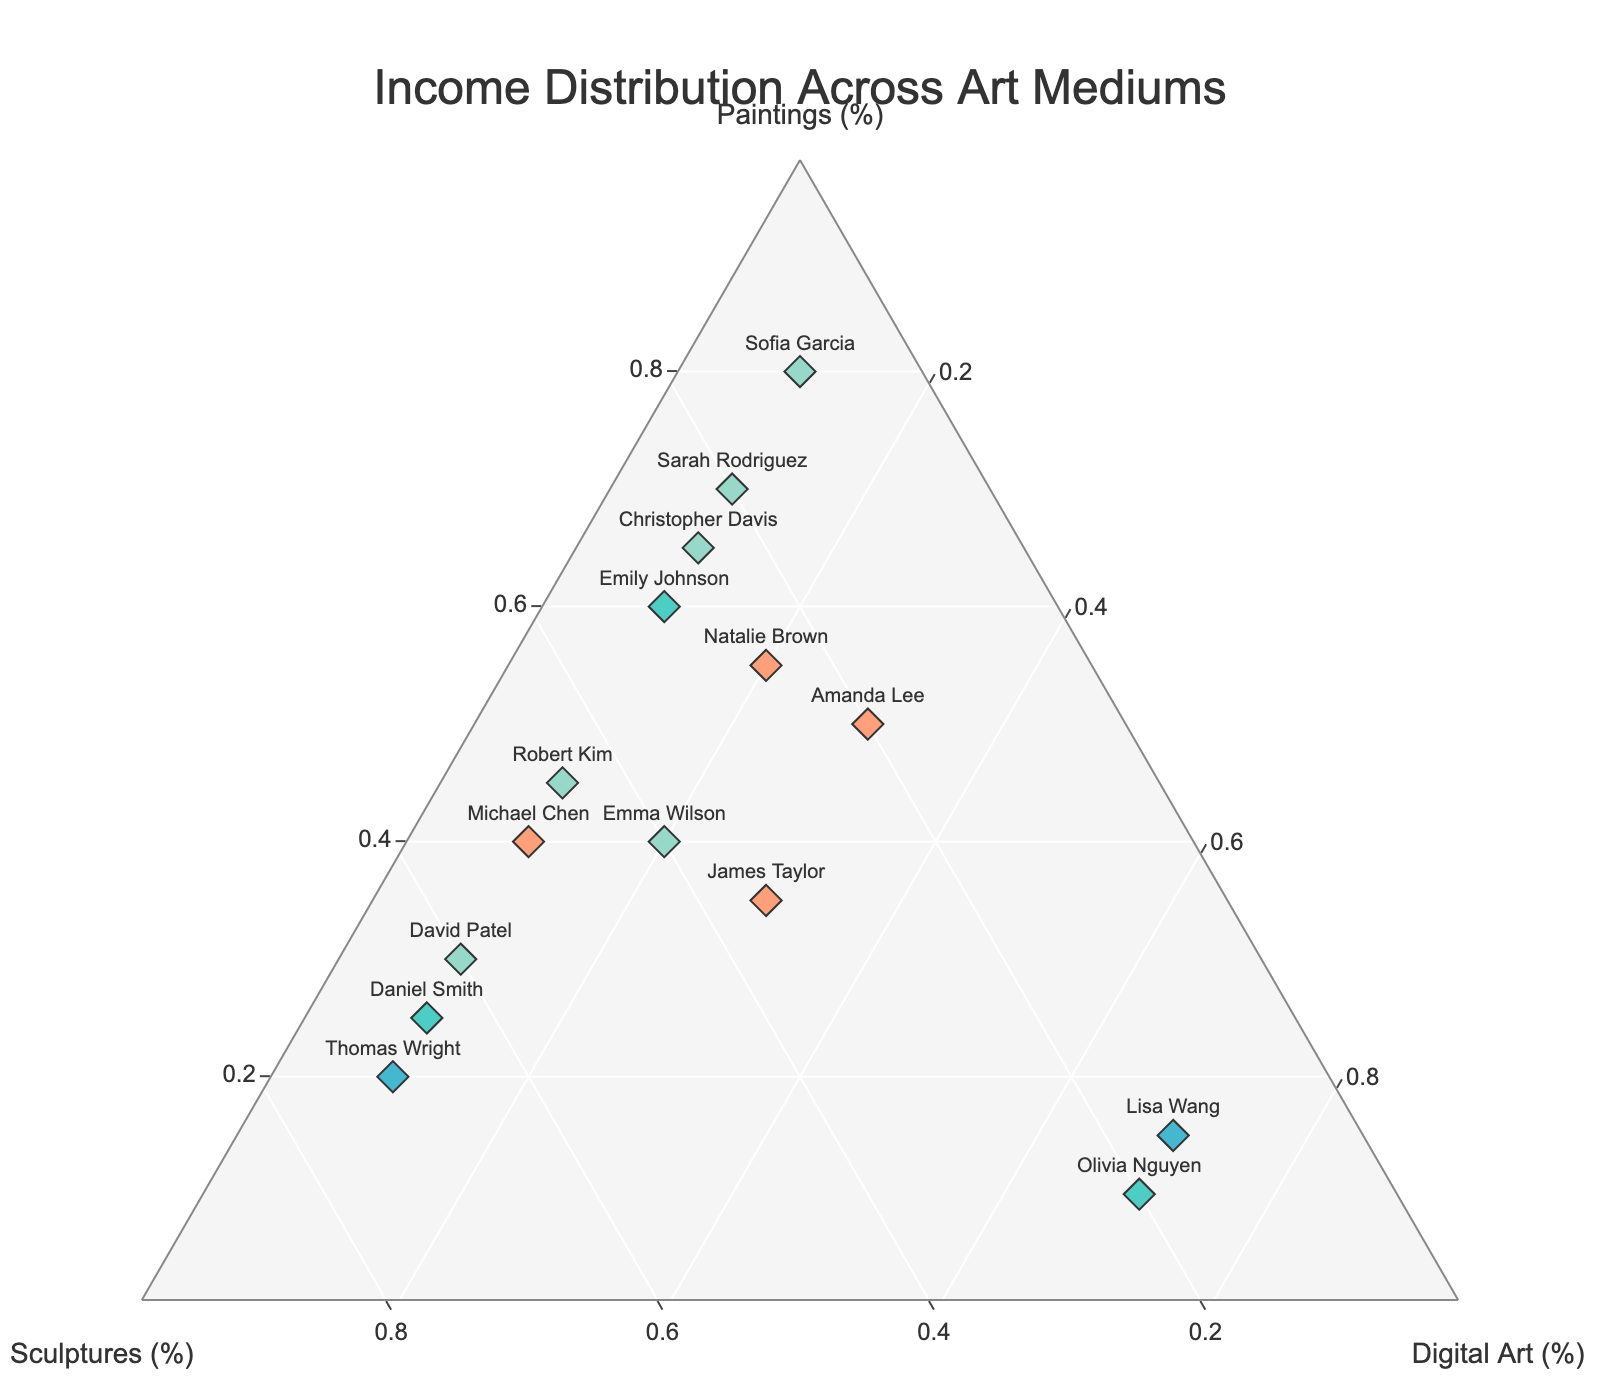What does the ternary plot's title indicate? The title "Income Distribution Across Art Mediums" suggests that the figure shows how different artists' incomes are distributed among paintings, sculptures, and digital art.
Answer: Income Distribution Across Art Mediums What are the axes titles in the ternary plot? The axes titles are "Paintings (%)", "Sculptures (%)", and "Digital Art (%)". Each axis represents the percentage of income from a specific art medium.
Answer: Paintings (%), Sculptures (%), Digital Art (%) Which artist has the highest percentage of income from sculptures? By looking at the ternary plot, the artist whose marker is positioned closest to the sculptures axis (70%) is Thomas Wright.
Answer: Thomas Wright What is the income distribution for Amanda Lee? Amanda Lee's marker is positioned at 50% paintings, 20% sculptures, and 30% digital art. These values are displayed on the plot.
Answer: 50% paintings, 20% sculptures, 30% digital art How many artists have an equal income distribution from paintings and sculptures? Artists with equal income from paintings and sculptures will have their markers along a line where the values for paintings and sculptures are the same. In this case, Michael Chen (40% paintings, 50% sculptures) and Robert Kim (45% paintings, 45% sculptures) fit this description.
Answer: 2 artists What is the total percentage contribution from digital art for all artists combined? To find the total percentage contribution from digital art, sum the digital art percentages for all artists: 10 + 10 + 10 + 10 + 30 + 10 + 70 + 10 + 10 + 30 + 20 + 10 + 70 + 10 + 20 = 320%.
Answer: 320% Which artist has the most balanced distribution of income across the three art mediums? The most balanced distribution would be where the three percentages are closest to each other. James Taylor, with 35% paintings, 35% sculptures, and 30% digital art, has the most balanced distribution.
Answer: James Taylor Who has the least percentage of income from digital art? By observing the markers on the ternary plot, the artist closest to the 0% digital art point is Sofia Garcia, with 10% digital art.
Answer: Sofia Garcia Compare the income distribution between David Patel and Daniel Smith. David Patel has 30% from paintings, 60% from sculptures, and 10% from digital art. Daniel Smith has 25% from paintings, 65% from sculptures, and 10% from digital art. Both have similar distributions but with slightly higher values for David Patel in paintings and slightly higher values for Daniel Smith in sculptures.
Answer: David Patel: 30% paintings, 60% sculptures, 10% digital art; Daniel Smith: 25% paintings, 65% sculptures, 10% digital art How many artists have more than 60% income from paintings? By examining the ternary plot, the artists positioned toward the high end of the paintings axis are Sarah Rodriguez (70%), Sofia Garcia (80%), and Christopher Davis (65%). Thus, there are 3 artists with more than 60% income from paintings.
Answer: 3 artists 